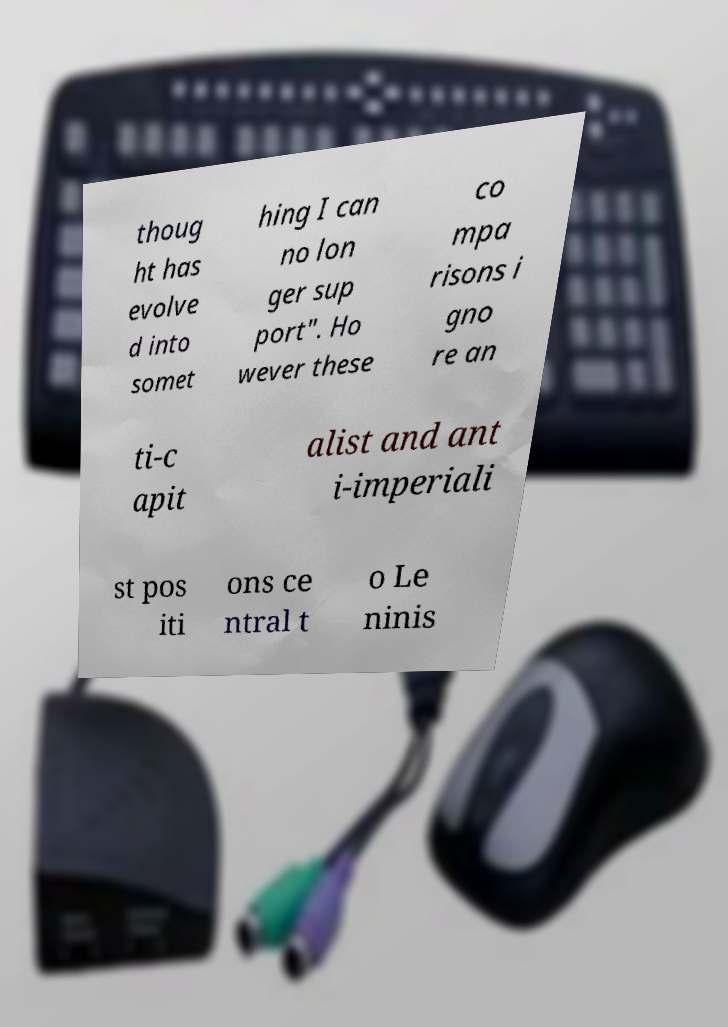Could you extract and type out the text from this image? thoug ht has evolve d into somet hing I can no lon ger sup port". Ho wever these co mpa risons i gno re an ti-c apit alist and ant i-imperiali st pos iti ons ce ntral t o Le ninis 